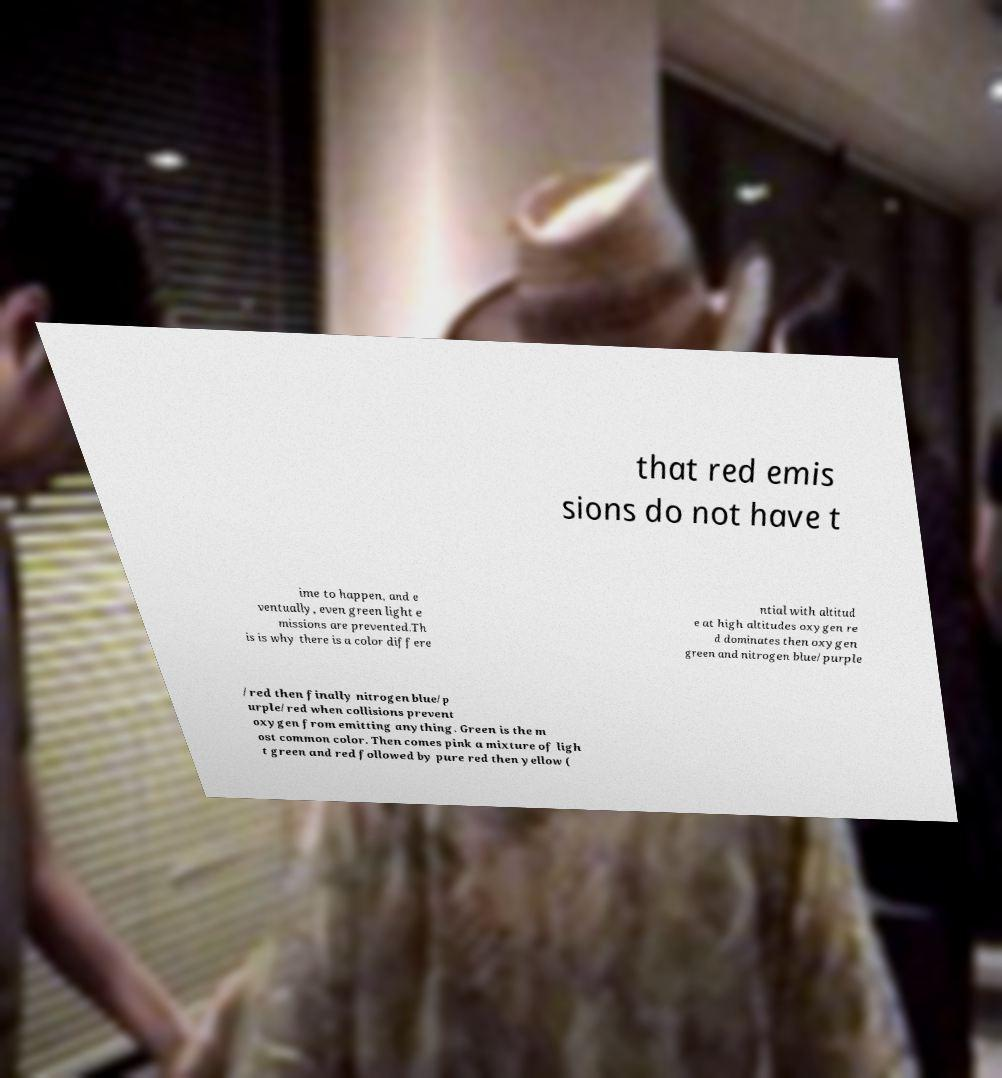For documentation purposes, I need the text within this image transcribed. Could you provide that? that red emis sions do not have t ime to happen, and e ventually, even green light e missions are prevented.Th is is why there is a color differe ntial with altitud e at high altitudes oxygen re d dominates then oxygen green and nitrogen blue/purple /red then finally nitrogen blue/p urple/red when collisions prevent oxygen from emitting anything. Green is the m ost common color. Then comes pink a mixture of ligh t green and red followed by pure red then yellow ( 